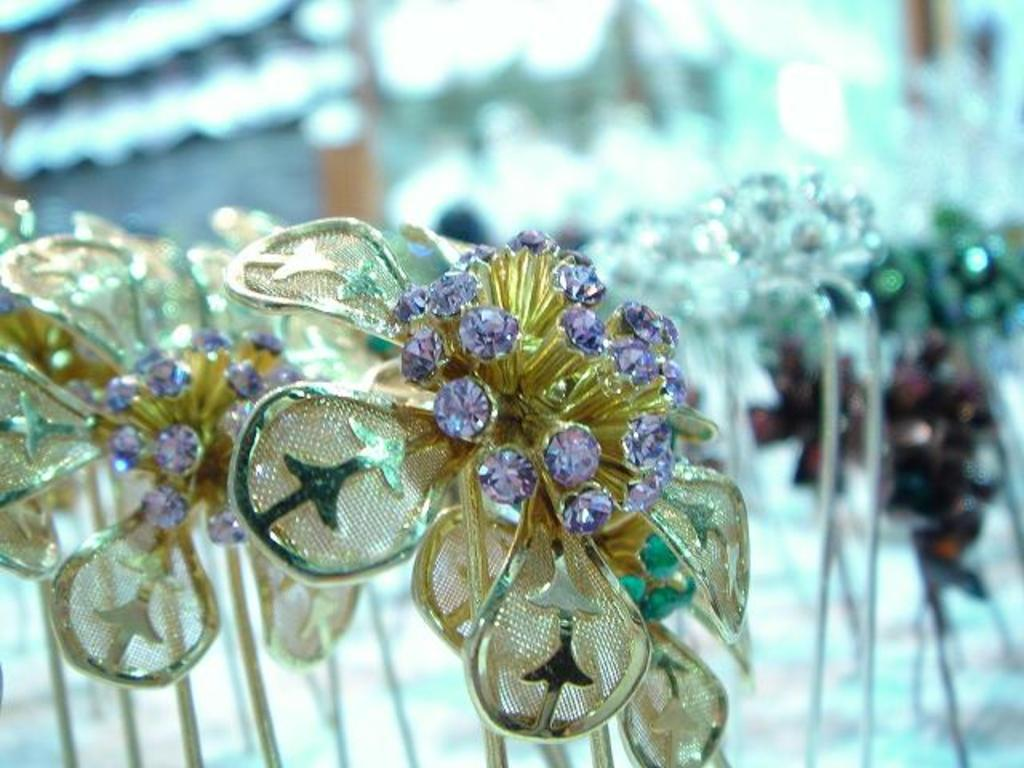What objects can be seen in the image? There are ornaments in the image. Can you describe the background of the image? The background of the image is blurred. What type of creature can be seen interacting with the ornaments in the image? There is no creature present in the image; it only features ornaments and a blurred background. 